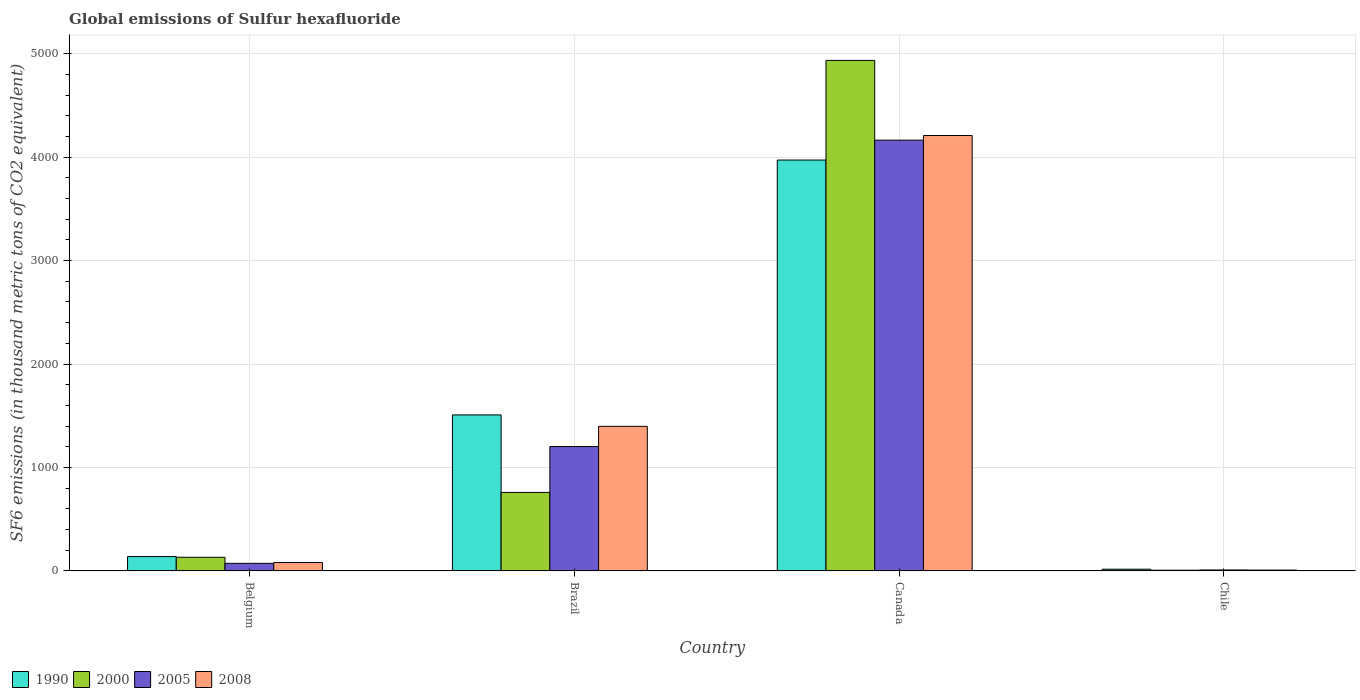Are the number of bars per tick equal to the number of legend labels?
Make the answer very short. Yes. How many bars are there on the 4th tick from the left?
Your answer should be compact. 4. What is the label of the 2nd group of bars from the left?
Provide a short and direct response. Brazil. What is the global emissions of Sulfur hexafluoride in 2008 in Belgium?
Offer a very short reply. 80.9. Across all countries, what is the maximum global emissions of Sulfur hexafluoride in 2000?
Your response must be concise. 4935.1. Across all countries, what is the minimum global emissions of Sulfur hexafluoride in 2005?
Your answer should be compact. 9. In which country was the global emissions of Sulfur hexafluoride in 2000 minimum?
Provide a succinct answer. Chile. What is the total global emissions of Sulfur hexafluoride in 2005 in the graph?
Make the answer very short. 5447.7. What is the difference between the global emissions of Sulfur hexafluoride in 2008 in Canada and that in Chile?
Give a very brief answer. 4200.9. What is the difference between the global emissions of Sulfur hexafluoride in 2005 in Canada and the global emissions of Sulfur hexafluoride in 2008 in Belgium?
Your response must be concise. 4082.9. What is the average global emissions of Sulfur hexafluoride in 2000 per country?
Offer a terse response. 1458.05. What is the difference between the global emissions of Sulfur hexafluoride of/in 2008 and global emissions of Sulfur hexafluoride of/in 2005 in Brazil?
Offer a terse response. 195.3. What is the ratio of the global emissions of Sulfur hexafluoride in 2000 in Belgium to that in Brazil?
Your answer should be very brief. 0.17. What is the difference between the highest and the second highest global emissions of Sulfur hexafluoride in 2000?
Provide a succinct answer. -627. What is the difference between the highest and the lowest global emissions of Sulfur hexafluoride in 2008?
Provide a short and direct response. 4200.9. Is it the case that in every country, the sum of the global emissions of Sulfur hexafluoride in 2000 and global emissions of Sulfur hexafluoride in 2005 is greater than the sum of global emissions of Sulfur hexafluoride in 1990 and global emissions of Sulfur hexafluoride in 2008?
Your response must be concise. No. What does the 3rd bar from the right in Canada represents?
Provide a short and direct response. 2000. What is the difference between two consecutive major ticks on the Y-axis?
Keep it short and to the point. 1000. Does the graph contain any zero values?
Give a very brief answer. No. Does the graph contain grids?
Ensure brevity in your answer.  Yes. How many legend labels are there?
Give a very brief answer. 4. How are the legend labels stacked?
Offer a terse response. Horizontal. What is the title of the graph?
Your response must be concise. Global emissions of Sulfur hexafluoride. What is the label or title of the X-axis?
Keep it short and to the point. Country. What is the label or title of the Y-axis?
Give a very brief answer. SF6 emissions (in thousand metric tons of CO2 equivalent). What is the SF6 emissions (in thousand metric tons of CO2 equivalent) of 1990 in Belgium?
Provide a short and direct response. 138.5. What is the SF6 emissions (in thousand metric tons of CO2 equivalent) in 2000 in Belgium?
Your answer should be compact. 131.7. What is the SF6 emissions (in thousand metric tons of CO2 equivalent) of 2005 in Belgium?
Your response must be concise. 72.9. What is the SF6 emissions (in thousand metric tons of CO2 equivalent) of 2008 in Belgium?
Provide a succinct answer. 80.9. What is the SF6 emissions (in thousand metric tons of CO2 equivalent) in 1990 in Brazil?
Your answer should be compact. 1507.9. What is the SF6 emissions (in thousand metric tons of CO2 equivalent) in 2000 in Brazil?
Keep it short and to the point. 758.7. What is the SF6 emissions (in thousand metric tons of CO2 equivalent) in 2005 in Brazil?
Provide a succinct answer. 1202. What is the SF6 emissions (in thousand metric tons of CO2 equivalent) of 2008 in Brazil?
Keep it short and to the point. 1397.3. What is the SF6 emissions (in thousand metric tons of CO2 equivalent) of 1990 in Canada?
Keep it short and to the point. 3971.8. What is the SF6 emissions (in thousand metric tons of CO2 equivalent) in 2000 in Canada?
Provide a short and direct response. 4935.1. What is the SF6 emissions (in thousand metric tons of CO2 equivalent) of 2005 in Canada?
Offer a terse response. 4163.8. What is the SF6 emissions (in thousand metric tons of CO2 equivalent) of 2008 in Canada?
Give a very brief answer. 4208.8. What is the SF6 emissions (in thousand metric tons of CO2 equivalent) of 2008 in Chile?
Keep it short and to the point. 7.9. Across all countries, what is the maximum SF6 emissions (in thousand metric tons of CO2 equivalent) in 1990?
Offer a very short reply. 3971.8. Across all countries, what is the maximum SF6 emissions (in thousand metric tons of CO2 equivalent) in 2000?
Your answer should be very brief. 4935.1. Across all countries, what is the maximum SF6 emissions (in thousand metric tons of CO2 equivalent) in 2005?
Provide a succinct answer. 4163.8. Across all countries, what is the maximum SF6 emissions (in thousand metric tons of CO2 equivalent) in 2008?
Your answer should be very brief. 4208.8. Across all countries, what is the minimum SF6 emissions (in thousand metric tons of CO2 equivalent) of 2000?
Your response must be concise. 6.7. Across all countries, what is the minimum SF6 emissions (in thousand metric tons of CO2 equivalent) of 2005?
Provide a succinct answer. 9. What is the total SF6 emissions (in thousand metric tons of CO2 equivalent) of 1990 in the graph?
Provide a succinct answer. 5634.7. What is the total SF6 emissions (in thousand metric tons of CO2 equivalent) in 2000 in the graph?
Offer a terse response. 5832.2. What is the total SF6 emissions (in thousand metric tons of CO2 equivalent) of 2005 in the graph?
Provide a succinct answer. 5447.7. What is the total SF6 emissions (in thousand metric tons of CO2 equivalent) in 2008 in the graph?
Ensure brevity in your answer.  5694.9. What is the difference between the SF6 emissions (in thousand metric tons of CO2 equivalent) in 1990 in Belgium and that in Brazil?
Your answer should be very brief. -1369.4. What is the difference between the SF6 emissions (in thousand metric tons of CO2 equivalent) in 2000 in Belgium and that in Brazil?
Give a very brief answer. -627. What is the difference between the SF6 emissions (in thousand metric tons of CO2 equivalent) in 2005 in Belgium and that in Brazil?
Ensure brevity in your answer.  -1129.1. What is the difference between the SF6 emissions (in thousand metric tons of CO2 equivalent) in 2008 in Belgium and that in Brazil?
Your answer should be very brief. -1316.4. What is the difference between the SF6 emissions (in thousand metric tons of CO2 equivalent) of 1990 in Belgium and that in Canada?
Keep it short and to the point. -3833.3. What is the difference between the SF6 emissions (in thousand metric tons of CO2 equivalent) of 2000 in Belgium and that in Canada?
Your answer should be very brief. -4803.4. What is the difference between the SF6 emissions (in thousand metric tons of CO2 equivalent) of 2005 in Belgium and that in Canada?
Provide a succinct answer. -4090.9. What is the difference between the SF6 emissions (in thousand metric tons of CO2 equivalent) of 2008 in Belgium and that in Canada?
Ensure brevity in your answer.  -4127.9. What is the difference between the SF6 emissions (in thousand metric tons of CO2 equivalent) in 1990 in Belgium and that in Chile?
Your answer should be very brief. 122. What is the difference between the SF6 emissions (in thousand metric tons of CO2 equivalent) in 2000 in Belgium and that in Chile?
Provide a short and direct response. 125. What is the difference between the SF6 emissions (in thousand metric tons of CO2 equivalent) in 2005 in Belgium and that in Chile?
Provide a succinct answer. 63.9. What is the difference between the SF6 emissions (in thousand metric tons of CO2 equivalent) in 1990 in Brazil and that in Canada?
Make the answer very short. -2463.9. What is the difference between the SF6 emissions (in thousand metric tons of CO2 equivalent) in 2000 in Brazil and that in Canada?
Your response must be concise. -4176.4. What is the difference between the SF6 emissions (in thousand metric tons of CO2 equivalent) in 2005 in Brazil and that in Canada?
Keep it short and to the point. -2961.8. What is the difference between the SF6 emissions (in thousand metric tons of CO2 equivalent) in 2008 in Brazil and that in Canada?
Offer a terse response. -2811.5. What is the difference between the SF6 emissions (in thousand metric tons of CO2 equivalent) of 1990 in Brazil and that in Chile?
Ensure brevity in your answer.  1491.4. What is the difference between the SF6 emissions (in thousand metric tons of CO2 equivalent) of 2000 in Brazil and that in Chile?
Offer a terse response. 752. What is the difference between the SF6 emissions (in thousand metric tons of CO2 equivalent) in 2005 in Brazil and that in Chile?
Keep it short and to the point. 1193. What is the difference between the SF6 emissions (in thousand metric tons of CO2 equivalent) in 2008 in Brazil and that in Chile?
Give a very brief answer. 1389.4. What is the difference between the SF6 emissions (in thousand metric tons of CO2 equivalent) of 1990 in Canada and that in Chile?
Make the answer very short. 3955.3. What is the difference between the SF6 emissions (in thousand metric tons of CO2 equivalent) in 2000 in Canada and that in Chile?
Your answer should be compact. 4928.4. What is the difference between the SF6 emissions (in thousand metric tons of CO2 equivalent) in 2005 in Canada and that in Chile?
Offer a terse response. 4154.8. What is the difference between the SF6 emissions (in thousand metric tons of CO2 equivalent) in 2008 in Canada and that in Chile?
Offer a very short reply. 4200.9. What is the difference between the SF6 emissions (in thousand metric tons of CO2 equivalent) in 1990 in Belgium and the SF6 emissions (in thousand metric tons of CO2 equivalent) in 2000 in Brazil?
Provide a succinct answer. -620.2. What is the difference between the SF6 emissions (in thousand metric tons of CO2 equivalent) of 1990 in Belgium and the SF6 emissions (in thousand metric tons of CO2 equivalent) of 2005 in Brazil?
Your answer should be very brief. -1063.5. What is the difference between the SF6 emissions (in thousand metric tons of CO2 equivalent) in 1990 in Belgium and the SF6 emissions (in thousand metric tons of CO2 equivalent) in 2008 in Brazil?
Offer a very short reply. -1258.8. What is the difference between the SF6 emissions (in thousand metric tons of CO2 equivalent) in 2000 in Belgium and the SF6 emissions (in thousand metric tons of CO2 equivalent) in 2005 in Brazil?
Offer a terse response. -1070.3. What is the difference between the SF6 emissions (in thousand metric tons of CO2 equivalent) in 2000 in Belgium and the SF6 emissions (in thousand metric tons of CO2 equivalent) in 2008 in Brazil?
Offer a very short reply. -1265.6. What is the difference between the SF6 emissions (in thousand metric tons of CO2 equivalent) of 2005 in Belgium and the SF6 emissions (in thousand metric tons of CO2 equivalent) of 2008 in Brazil?
Your answer should be compact. -1324.4. What is the difference between the SF6 emissions (in thousand metric tons of CO2 equivalent) in 1990 in Belgium and the SF6 emissions (in thousand metric tons of CO2 equivalent) in 2000 in Canada?
Offer a terse response. -4796.6. What is the difference between the SF6 emissions (in thousand metric tons of CO2 equivalent) in 1990 in Belgium and the SF6 emissions (in thousand metric tons of CO2 equivalent) in 2005 in Canada?
Your answer should be compact. -4025.3. What is the difference between the SF6 emissions (in thousand metric tons of CO2 equivalent) of 1990 in Belgium and the SF6 emissions (in thousand metric tons of CO2 equivalent) of 2008 in Canada?
Provide a succinct answer. -4070.3. What is the difference between the SF6 emissions (in thousand metric tons of CO2 equivalent) of 2000 in Belgium and the SF6 emissions (in thousand metric tons of CO2 equivalent) of 2005 in Canada?
Give a very brief answer. -4032.1. What is the difference between the SF6 emissions (in thousand metric tons of CO2 equivalent) in 2000 in Belgium and the SF6 emissions (in thousand metric tons of CO2 equivalent) in 2008 in Canada?
Ensure brevity in your answer.  -4077.1. What is the difference between the SF6 emissions (in thousand metric tons of CO2 equivalent) of 2005 in Belgium and the SF6 emissions (in thousand metric tons of CO2 equivalent) of 2008 in Canada?
Offer a terse response. -4135.9. What is the difference between the SF6 emissions (in thousand metric tons of CO2 equivalent) of 1990 in Belgium and the SF6 emissions (in thousand metric tons of CO2 equivalent) of 2000 in Chile?
Make the answer very short. 131.8. What is the difference between the SF6 emissions (in thousand metric tons of CO2 equivalent) of 1990 in Belgium and the SF6 emissions (in thousand metric tons of CO2 equivalent) of 2005 in Chile?
Your response must be concise. 129.5. What is the difference between the SF6 emissions (in thousand metric tons of CO2 equivalent) in 1990 in Belgium and the SF6 emissions (in thousand metric tons of CO2 equivalent) in 2008 in Chile?
Ensure brevity in your answer.  130.6. What is the difference between the SF6 emissions (in thousand metric tons of CO2 equivalent) in 2000 in Belgium and the SF6 emissions (in thousand metric tons of CO2 equivalent) in 2005 in Chile?
Offer a terse response. 122.7. What is the difference between the SF6 emissions (in thousand metric tons of CO2 equivalent) in 2000 in Belgium and the SF6 emissions (in thousand metric tons of CO2 equivalent) in 2008 in Chile?
Offer a terse response. 123.8. What is the difference between the SF6 emissions (in thousand metric tons of CO2 equivalent) of 1990 in Brazil and the SF6 emissions (in thousand metric tons of CO2 equivalent) of 2000 in Canada?
Offer a terse response. -3427.2. What is the difference between the SF6 emissions (in thousand metric tons of CO2 equivalent) of 1990 in Brazil and the SF6 emissions (in thousand metric tons of CO2 equivalent) of 2005 in Canada?
Provide a short and direct response. -2655.9. What is the difference between the SF6 emissions (in thousand metric tons of CO2 equivalent) in 1990 in Brazil and the SF6 emissions (in thousand metric tons of CO2 equivalent) in 2008 in Canada?
Your answer should be compact. -2700.9. What is the difference between the SF6 emissions (in thousand metric tons of CO2 equivalent) in 2000 in Brazil and the SF6 emissions (in thousand metric tons of CO2 equivalent) in 2005 in Canada?
Offer a very short reply. -3405.1. What is the difference between the SF6 emissions (in thousand metric tons of CO2 equivalent) of 2000 in Brazil and the SF6 emissions (in thousand metric tons of CO2 equivalent) of 2008 in Canada?
Give a very brief answer. -3450.1. What is the difference between the SF6 emissions (in thousand metric tons of CO2 equivalent) in 2005 in Brazil and the SF6 emissions (in thousand metric tons of CO2 equivalent) in 2008 in Canada?
Give a very brief answer. -3006.8. What is the difference between the SF6 emissions (in thousand metric tons of CO2 equivalent) of 1990 in Brazil and the SF6 emissions (in thousand metric tons of CO2 equivalent) of 2000 in Chile?
Offer a terse response. 1501.2. What is the difference between the SF6 emissions (in thousand metric tons of CO2 equivalent) in 1990 in Brazil and the SF6 emissions (in thousand metric tons of CO2 equivalent) in 2005 in Chile?
Make the answer very short. 1498.9. What is the difference between the SF6 emissions (in thousand metric tons of CO2 equivalent) in 1990 in Brazil and the SF6 emissions (in thousand metric tons of CO2 equivalent) in 2008 in Chile?
Offer a very short reply. 1500. What is the difference between the SF6 emissions (in thousand metric tons of CO2 equivalent) of 2000 in Brazil and the SF6 emissions (in thousand metric tons of CO2 equivalent) of 2005 in Chile?
Offer a terse response. 749.7. What is the difference between the SF6 emissions (in thousand metric tons of CO2 equivalent) of 2000 in Brazil and the SF6 emissions (in thousand metric tons of CO2 equivalent) of 2008 in Chile?
Your answer should be very brief. 750.8. What is the difference between the SF6 emissions (in thousand metric tons of CO2 equivalent) of 2005 in Brazil and the SF6 emissions (in thousand metric tons of CO2 equivalent) of 2008 in Chile?
Give a very brief answer. 1194.1. What is the difference between the SF6 emissions (in thousand metric tons of CO2 equivalent) in 1990 in Canada and the SF6 emissions (in thousand metric tons of CO2 equivalent) in 2000 in Chile?
Your response must be concise. 3965.1. What is the difference between the SF6 emissions (in thousand metric tons of CO2 equivalent) in 1990 in Canada and the SF6 emissions (in thousand metric tons of CO2 equivalent) in 2005 in Chile?
Your answer should be very brief. 3962.8. What is the difference between the SF6 emissions (in thousand metric tons of CO2 equivalent) in 1990 in Canada and the SF6 emissions (in thousand metric tons of CO2 equivalent) in 2008 in Chile?
Make the answer very short. 3963.9. What is the difference between the SF6 emissions (in thousand metric tons of CO2 equivalent) of 2000 in Canada and the SF6 emissions (in thousand metric tons of CO2 equivalent) of 2005 in Chile?
Provide a short and direct response. 4926.1. What is the difference between the SF6 emissions (in thousand metric tons of CO2 equivalent) in 2000 in Canada and the SF6 emissions (in thousand metric tons of CO2 equivalent) in 2008 in Chile?
Your answer should be very brief. 4927.2. What is the difference between the SF6 emissions (in thousand metric tons of CO2 equivalent) of 2005 in Canada and the SF6 emissions (in thousand metric tons of CO2 equivalent) of 2008 in Chile?
Offer a very short reply. 4155.9. What is the average SF6 emissions (in thousand metric tons of CO2 equivalent) in 1990 per country?
Offer a terse response. 1408.67. What is the average SF6 emissions (in thousand metric tons of CO2 equivalent) of 2000 per country?
Provide a succinct answer. 1458.05. What is the average SF6 emissions (in thousand metric tons of CO2 equivalent) of 2005 per country?
Make the answer very short. 1361.92. What is the average SF6 emissions (in thousand metric tons of CO2 equivalent) in 2008 per country?
Your answer should be compact. 1423.72. What is the difference between the SF6 emissions (in thousand metric tons of CO2 equivalent) in 1990 and SF6 emissions (in thousand metric tons of CO2 equivalent) in 2005 in Belgium?
Your answer should be compact. 65.6. What is the difference between the SF6 emissions (in thousand metric tons of CO2 equivalent) of 1990 and SF6 emissions (in thousand metric tons of CO2 equivalent) of 2008 in Belgium?
Give a very brief answer. 57.6. What is the difference between the SF6 emissions (in thousand metric tons of CO2 equivalent) of 2000 and SF6 emissions (in thousand metric tons of CO2 equivalent) of 2005 in Belgium?
Make the answer very short. 58.8. What is the difference between the SF6 emissions (in thousand metric tons of CO2 equivalent) of 2000 and SF6 emissions (in thousand metric tons of CO2 equivalent) of 2008 in Belgium?
Your answer should be very brief. 50.8. What is the difference between the SF6 emissions (in thousand metric tons of CO2 equivalent) of 2005 and SF6 emissions (in thousand metric tons of CO2 equivalent) of 2008 in Belgium?
Offer a very short reply. -8. What is the difference between the SF6 emissions (in thousand metric tons of CO2 equivalent) in 1990 and SF6 emissions (in thousand metric tons of CO2 equivalent) in 2000 in Brazil?
Ensure brevity in your answer.  749.2. What is the difference between the SF6 emissions (in thousand metric tons of CO2 equivalent) in 1990 and SF6 emissions (in thousand metric tons of CO2 equivalent) in 2005 in Brazil?
Ensure brevity in your answer.  305.9. What is the difference between the SF6 emissions (in thousand metric tons of CO2 equivalent) of 1990 and SF6 emissions (in thousand metric tons of CO2 equivalent) of 2008 in Brazil?
Give a very brief answer. 110.6. What is the difference between the SF6 emissions (in thousand metric tons of CO2 equivalent) in 2000 and SF6 emissions (in thousand metric tons of CO2 equivalent) in 2005 in Brazil?
Your response must be concise. -443.3. What is the difference between the SF6 emissions (in thousand metric tons of CO2 equivalent) in 2000 and SF6 emissions (in thousand metric tons of CO2 equivalent) in 2008 in Brazil?
Give a very brief answer. -638.6. What is the difference between the SF6 emissions (in thousand metric tons of CO2 equivalent) of 2005 and SF6 emissions (in thousand metric tons of CO2 equivalent) of 2008 in Brazil?
Your answer should be compact. -195.3. What is the difference between the SF6 emissions (in thousand metric tons of CO2 equivalent) in 1990 and SF6 emissions (in thousand metric tons of CO2 equivalent) in 2000 in Canada?
Offer a very short reply. -963.3. What is the difference between the SF6 emissions (in thousand metric tons of CO2 equivalent) of 1990 and SF6 emissions (in thousand metric tons of CO2 equivalent) of 2005 in Canada?
Keep it short and to the point. -192. What is the difference between the SF6 emissions (in thousand metric tons of CO2 equivalent) of 1990 and SF6 emissions (in thousand metric tons of CO2 equivalent) of 2008 in Canada?
Keep it short and to the point. -237. What is the difference between the SF6 emissions (in thousand metric tons of CO2 equivalent) in 2000 and SF6 emissions (in thousand metric tons of CO2 equivalent) in 2005 in Canada?
Your answer should be compact. 771.3. What is the difference between the SF6 emissions (in thousand metric tons of CO2 equivalent) of 2000 and SF6 emissions (in thousand metric tons of CO2 equivalent) of 2008 in Canada?
Give a very brief answer. 726.3. What is the difference between the SF6 emissions (in thousand metric tons of CO2 equivalent) in 2005 and SF6 emissions (in thousand metric tons of CO2 equivalent) in 2008 in Canada?
Keep it short and to the point. -45. What is the difference between the SF6 emissions (in thousand metric tons of CO2 equivalent) of 2005 and SF6 emissions (in thousand metric tons of CO2 equivalent) of 2008 in Chile?
Your answer should be compact. 1.1. What is the ratio of the SF6 emissions (in thousand metric tons of CO2 equivalent) in 1990 in Belgium to that in Brazil?
Your answer should be compact. 0.09. What is the ratio of the SF6 emissions (in thousand metric tons of CO2 equivalent) in 2000 in Belgium to that in Brazil?
Offer a very short reply. 0.17. What is the ratio of the SF6 emissions (in thousand metric tons of CO2 equivalent) in 2005 in Belgium to that in Brazil?
Provide a succinct answer. 0.06. What is the ratio of the SF6 emissions (in thousand metric tons of CO2 equivalent) of 2008 in Belgium to that in Brazil?
Your answer should be very brief. 0.06. What is the ratio of the SF6 emissions (in thousand metric tons of CO2 equivalent) of 1990 in Belgium to that in Canada?
Your answer should be compact. 0.03. What is the ratio of the SF6 emissions (in thousand metric tons of CO2 equivalent) of 2000 in Belgium to that in Canada?
Make the answer very short. 0.03. What is the ratio of the SF6 emissions (in thousand metric tons of CO2 equivalent) in 2005 in Belgium to that in Canada?
Give a very brief answer. 0.02. What is the ratio of the SF6 emissions (in thousand metric tons of CO2 equivalent) in 2008 in Belgium to that in Canada?
Offer a very short reply. 0.02. What is the ratio of the SF6 emissions (in thousand metric tons of CO2 equivalent) in 1990 in Belgium to that in Chile?
Make the answer very short. 8.39. What is the ratio of the SF6 emissions (in thousand metric tons of CO2 equivalent) of 2000 in Belgium to that in Chile?
Make the answer very short. 19.66. What is the ratio of the SF6 emissions (in thousand metric tons of CO2 equivalent) in 2005 in Belgium to that in Chile?
Ensure brevity in your answer.  8.1. What is the ratio of the SF6 emissions (in thousand metric tons of CO2 equivalent) of 2008 in Belgium to that in Chile?
Provide a short and direct response. 10.24. What is the ratio of the SF6 emissions (in thousand metric tons of CO2 equivalent) in 1990 in Brazil to that in Canada?
Ensure brevity in your answer.  0.38. What is the ratio of the SF6 emissions (in thousand metric tons of CO2 equivalent) in 2000 in Brazil to that in Canada?
Your response must be concise. 0.15. What is the ratio of the SF6 emissions (in thousand metric tons of CO2 equivalent) of 2005 in Brazil to that in Canada?
Provide a succinct answer. 0.29. What is the ratio of the SF6 emissions (in thousand metric tons of CO2 equivalent) in 2008 in Brazil to that in Canada?
Offer a very short reply. 0.33. What is the ratio of the SF6 emissions (in thousand metric tons of CO2 equivalent) in 1990 in Brazil to that in Chile?
Provide a succinct answer. 91.39. What is the ratio of the SF6 emissions (in thousand metric tons of CO2 equivalent) in 2000 in Brazil to that in Chile?
Your answer should be very brief. 113.24. What is the ratio of the SF6 emissions (in thousand metric tons of CO2 equivalent) in 2005 in Brazil to that in Chile?
Offer a terse response. 133.56. What is the ratio of the SF6 emissions (in thousand metric tons of CO2 equivalent) of 2008 in Brazil to that in Chile?
Your answer should be compact. 176.87. What is the ratio of the SF6 emissions (in thousand metric tons of CO2 equivalent) of 1990 in Canada to that in Chile?
Your response must be concise. 240.72. What is the ratio of the SF6 emissions (in thousand metric tons of CO2 equivalent) in 2000 in Canada to that in Chile?
Provide a short and direct response. 736.58. What is the ratio of the SF6 emissions (in thousand metric tons of CO2 equivalent) of 2005 in Canada to that in Chile?
Keep it short and to the point. 462.64. What is the ratio of the SF6 emissions (in thousand metric tons of CO2 equivalent) of 2008 in Canada to that in Chile?
Offer a very short reply. 532.76. What is the difference between the highest and the second highest SF6 emissions (in thousand metric tons of CO2 equivalent) in 1990?
Give a very brief answer. 2463.9. What is the difference between the highest and the second highest SF6 emissions (in thousand metric tons of CO2 equivalent) of 2000?
Give a very brief answer. 4176.4. What is the difference between the highest and the second highest SF6 emissions (in thousand metric tons of CO2 equivalent) of 2005?
Your answer should be compact. 2961.8. What is the difference between the highest and the second highest SF6 emissions (in thousand metric tons of CO2 equivalent) in 2008?
Offer a very short reply. 2811.5. What is the difference between the highest and the lowest SF6 emissions (in thousand metric tons of CO2 equivalent) in 1990?
Your response must be concise. 3955.3. What is the difference between the highest and the lowest SF6 emissions (in thousand metric tons of CO2 equivalent) in 2000?
Keep it short and to the point. 4928.4. What is the difference between the highest and the lowest SF6 emissions (in thousand metric tons of CO2 equivalent) in 2005?
Make the answer very short. 4154.8. What is the difference between the highest and the lowest SF6 emissions (in thousand metric tons of CO2 equivalent) of 2008?
Provide a short and direct response. 4200.9. 